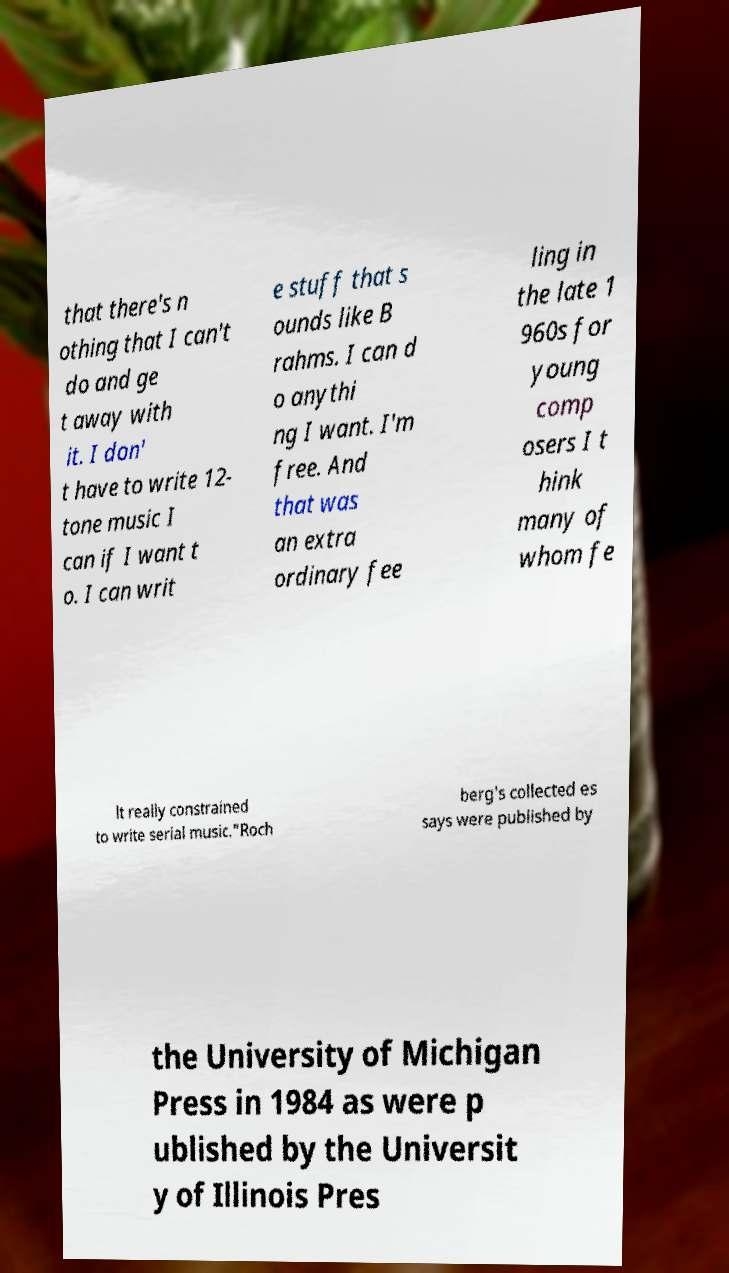There's text embedded in this image that I need extracted. Can you transcribe it verbatim? that there's n othing that I can't do and ge t away with it. I don' t have to write 12- tone music I can if I want t o. I can writ e stuff that s ounds like B rahms. I can d o anythi ng I want. I'm free. And that was an extra ordinary fee ling in the late 1 960s for young comp osers I t hink many of whom fe lt really constrained to write serial music."Roch berg's collected es says were published by the University of Michigan Press in 1984 as were p ublished by the Universit y of Illinois Pres 